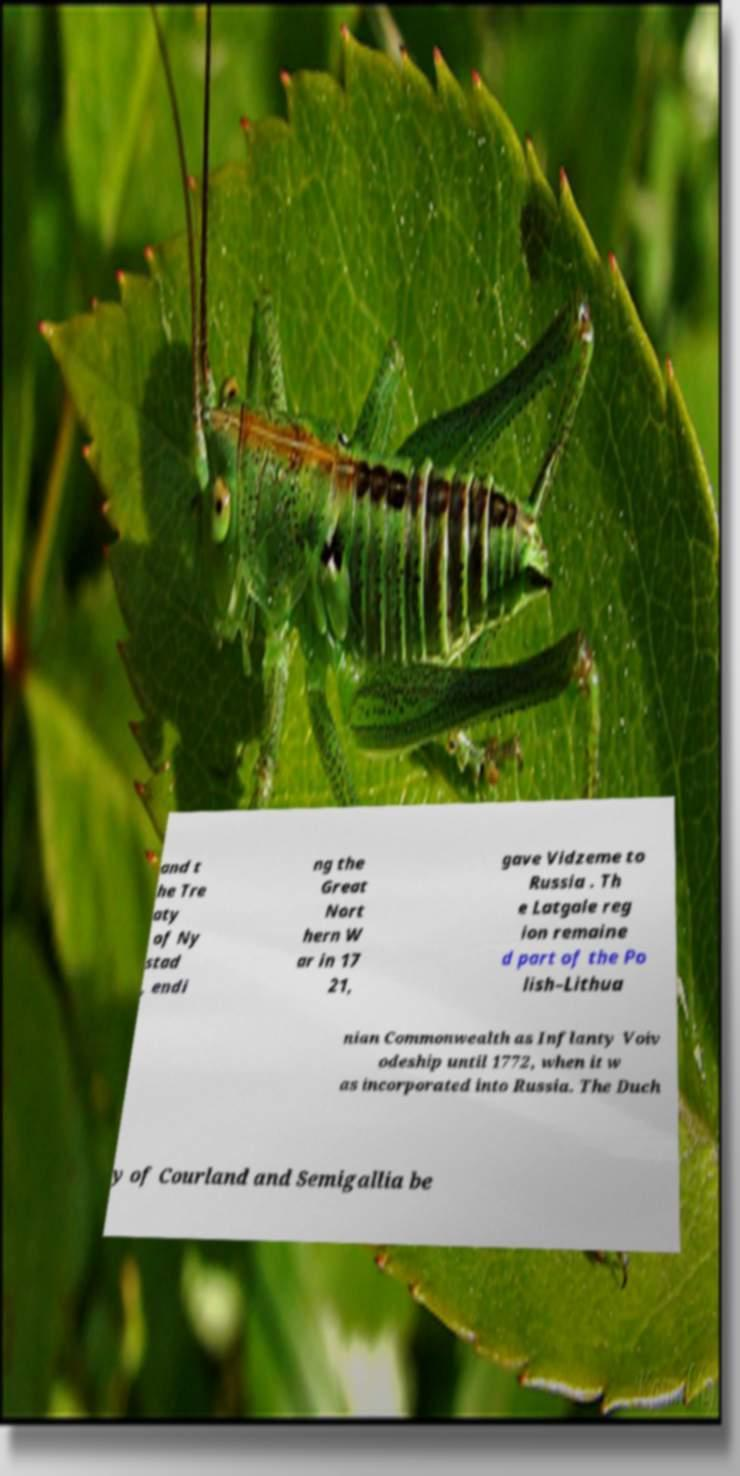Could you extract and type out the text from this image? and t he Tre aty of Ny stad , endi ng the Great Nort hern W ar in 17 21, gave Vidzeme to Russia . Th e Latgale reg ion remaine d part of the Po lish–Lithua nian Commonwealth as Inflanty Voiv odeship until 1772, when it w as incorporated into Russia. The Duch y of Courland and Semigallia be 